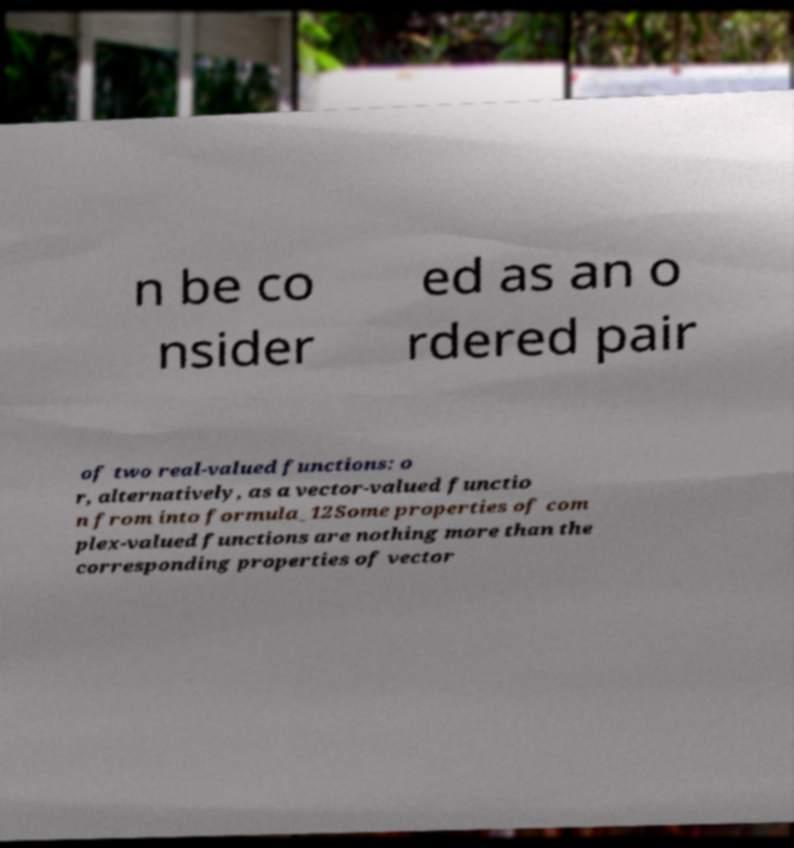Can you accurately transcribe the text from the provided image for me? n be co nsider ed as an o rdered pair of two real-valued functions: o r, alternatively, as a vector-valued functio n from into formula_12Some properties of com plex-valued functions are nothing more than the corresponding properties of vector 